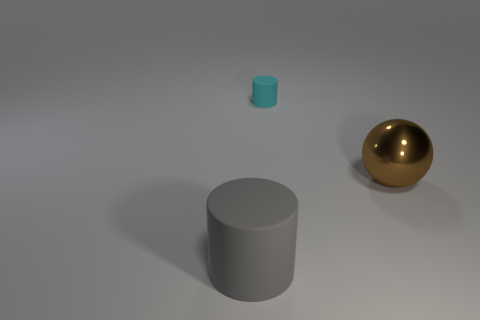Add 2 tiny red matte balls. How many objects exist? 5 Subtract all balls. How many objects are left? 2 Subtract all big brown shiny balls. Subtract all large cyan shiny objects. How many objects are left? 2 Add 1 big rubber cylinders. How many big rubber cylinders are left? 2 Add 3 big metallic things. How many big metallic things exist? 4 Subtract 0 cyan cubes. How many objects are left? 3 